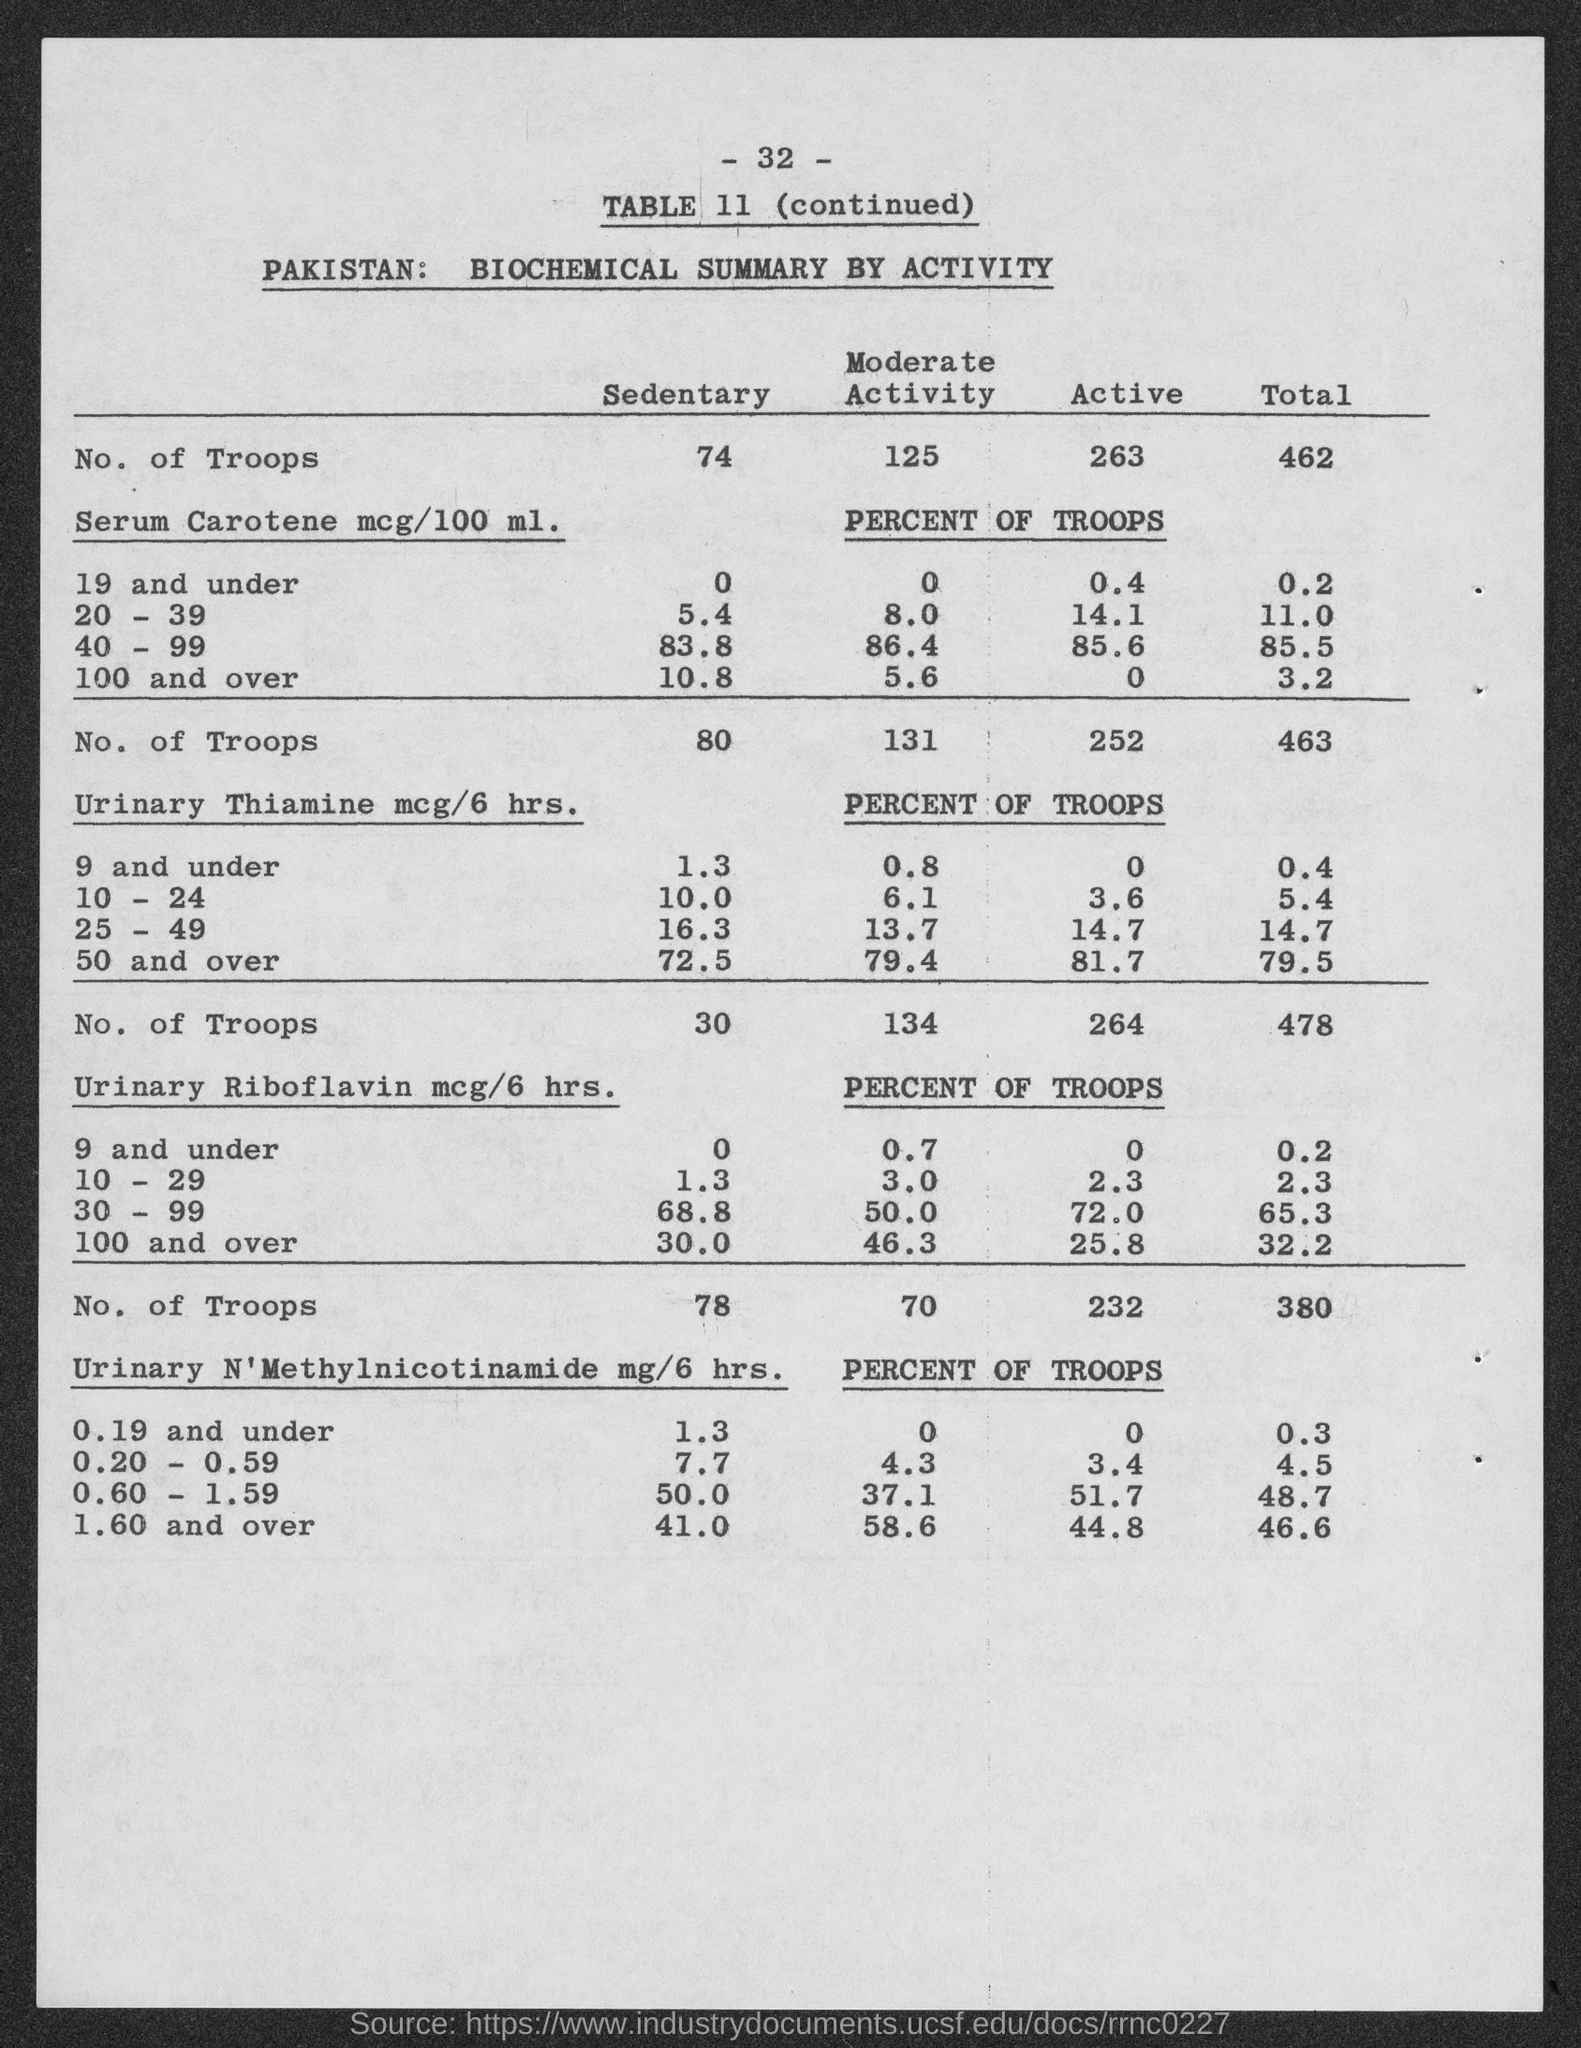List a handful of essential elements in this visual. The table number is 11. The number at the top of the page is -32-. 